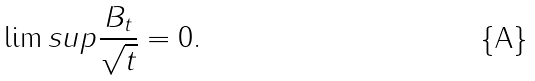<formula> <loc_0><loc_0><loc_500><loc_500>\lim s u p \frac { { B } _ { t } } { \sqrt { t } } = 0 .</formula> 